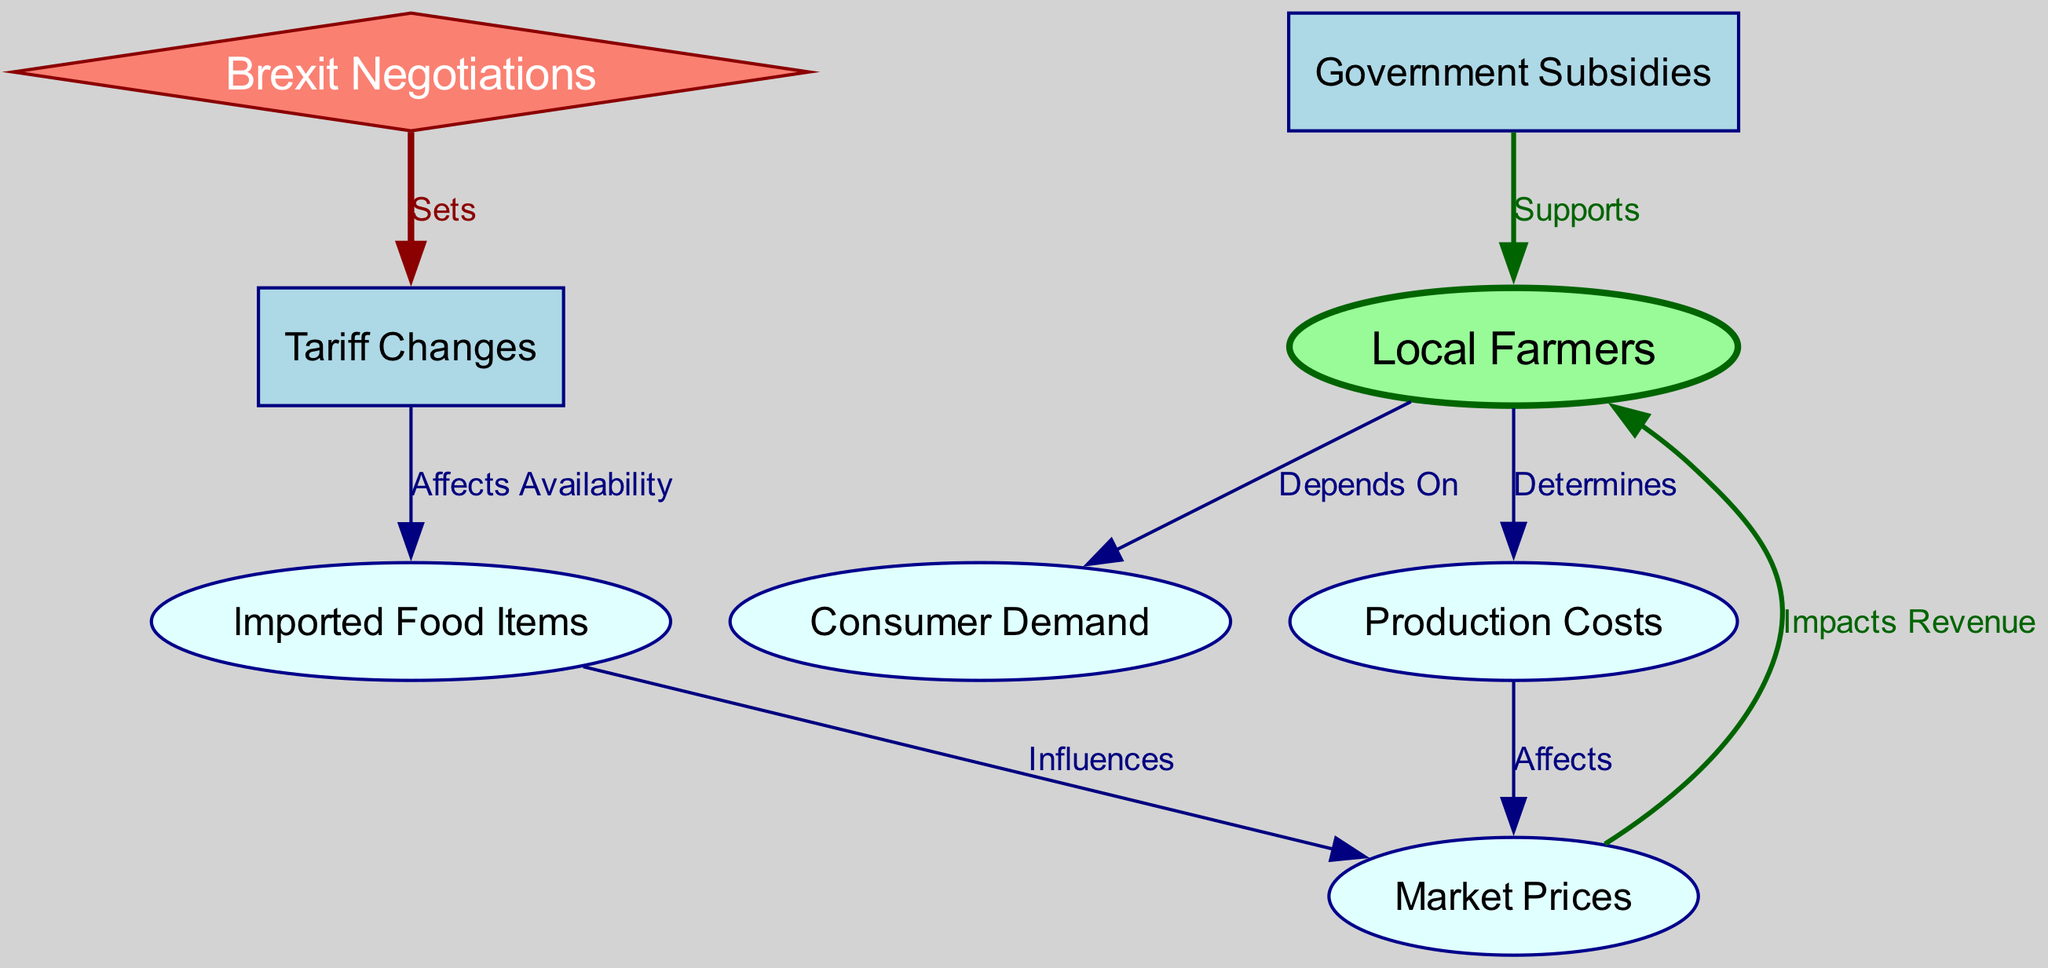What is the total number of nodes in the diagram? The diagram features a total of 8 nodes, which include local farmers, tariffs, imported food items, market prices, consumer demand, production costs, government subsidies, and Brexit negotiations.
Answer: 8 Which node directly influences market prices? The node identified as imported food items has a direct influence over market prices as indicated by the edge labeled "Influences."
Answer: Imported food items What is the relationship between tariffs and local farmers? The relationship is indirect; tariffs affect imported food items, which then influence market prices, ultimately impacting the revenue of local farmers.
Answer: Indirect influence Which node supports local farmers? Government subsidies is the node that supports local farmers as shown by the edge labeled "Supports."
Answer: Government subsidies How many edges are present in the diagram? The diagram comprises a total of 7 edges, which define the relationships between the various nodes represented.
Answer: 7 What does consumer demand depend on? Consumer demand is predominantly dependent on local farmers as denoted by the edge labeled "Depends On."
Answer: Local farmers If tariffs are set during Brexit negotiations, which node is affected immediately? The immediate effect of tariffs being set is on imported food items, as indicated by the edge showing that tariffs affect the availability of these items.
Answer: Imported food items What impacts the revenue of local farmers? The revenue of local farmers is impacted by market prices, as indicated by the edge labeled "Impacts Revenue."
Answer: Market prices What action do Brexit negotiations take concerning tariffs? Brexit negotiations set the tariffs, establishing guidelines that influence future trade policies and their implications.
Answer: Sets 